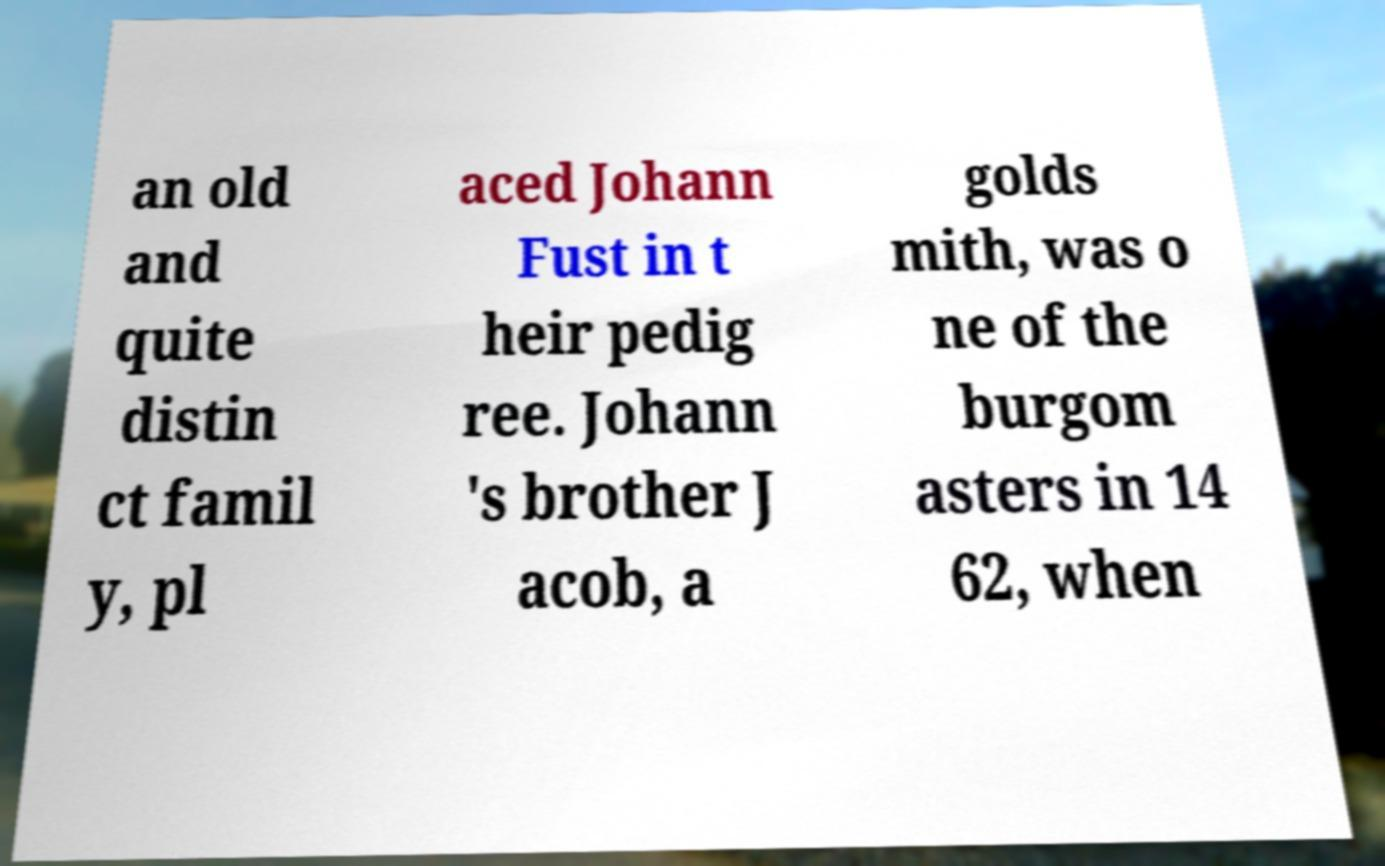Please read and relay the text visible in this image. What does it say? an old and quite distin ct famil y, pl aced Johann Fust in t heir pedig ree. Johann 's brother J acob, a golds mith, was o ne of the burgom asters in 14 62, when 